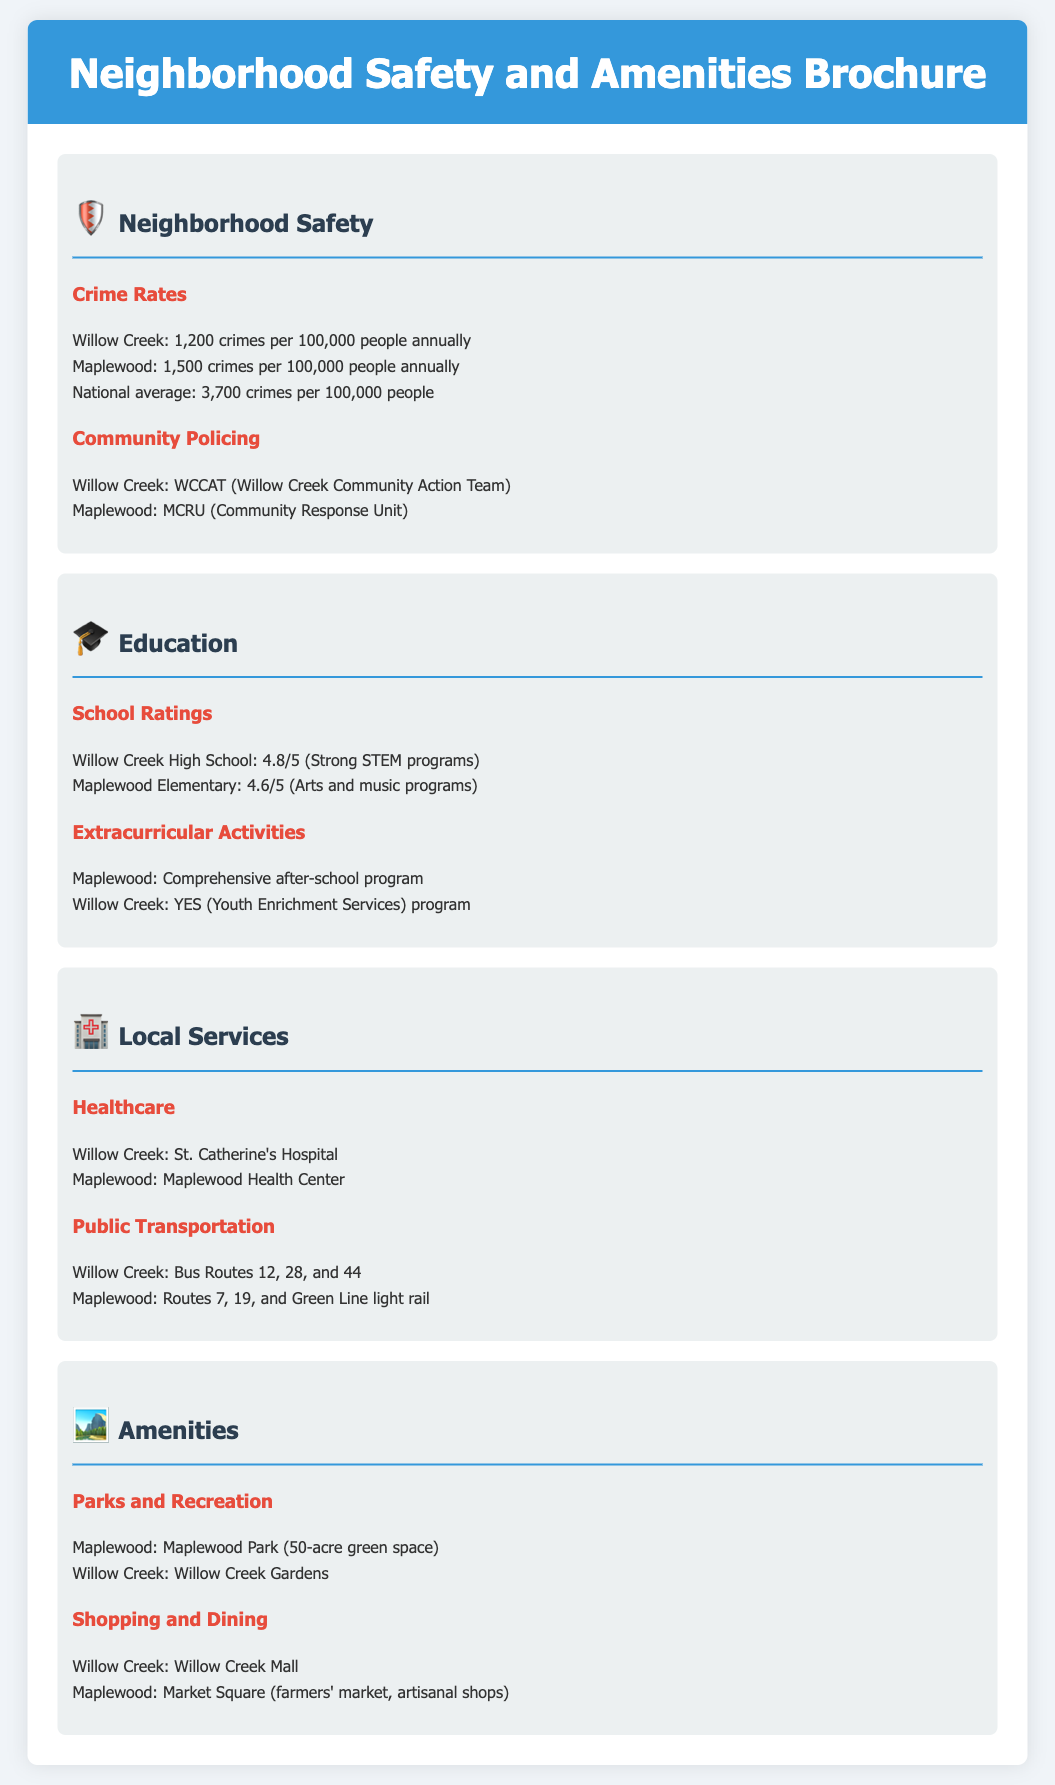What is the crime rate in Willow Creek? The document states that Willow Creek has a crime rate of 1,200 crimes per 100,000 people annually.
Answer: 1,200 crimes per 100,000 people What community policing team is in Maplewood? According to the document, Maplewood has the MCRU (Community Response Unit) as their community policing team.
Answer: MCRU What is the school rating for Willow Creek High School? The document indicates that Willow Creek High School has a rating of 4.8 out of 5.
Answer: 4.8/5 Which park is associated with Maplewood? The document mentions that Maplewood has Maplewood Park, a 50-acre green space.
Answer: Maplewood Park What public transportation route is available in Willow Creek? The document lists bus Routes 12, 28, and 44 as the public transportation options in Willow Creek.
Answer: Routes 12, 28, and 44 Which neighborhood has strong STEM programs in schools? The document specifies that Willow Creek High School has strong STEM programs.
Answer: Willow Creek Which neighborhood has a healthcare facility named St. Catherine's Hospital? St. Catherine's Hospital is mentioned as the healthcare facility in Willow Creek according to the document.
Answer: Willow Creek What is a local amenity in Willow Creek? The document states that Willow Creek Mall is a local amenity in Willow Creek.
Answer: Willow Creek Mall What extracurricular program is available in Maplewood? The document mentions that Maplewood offers a comprehensive after-school program.
Answer: Comprehensive after-school program 